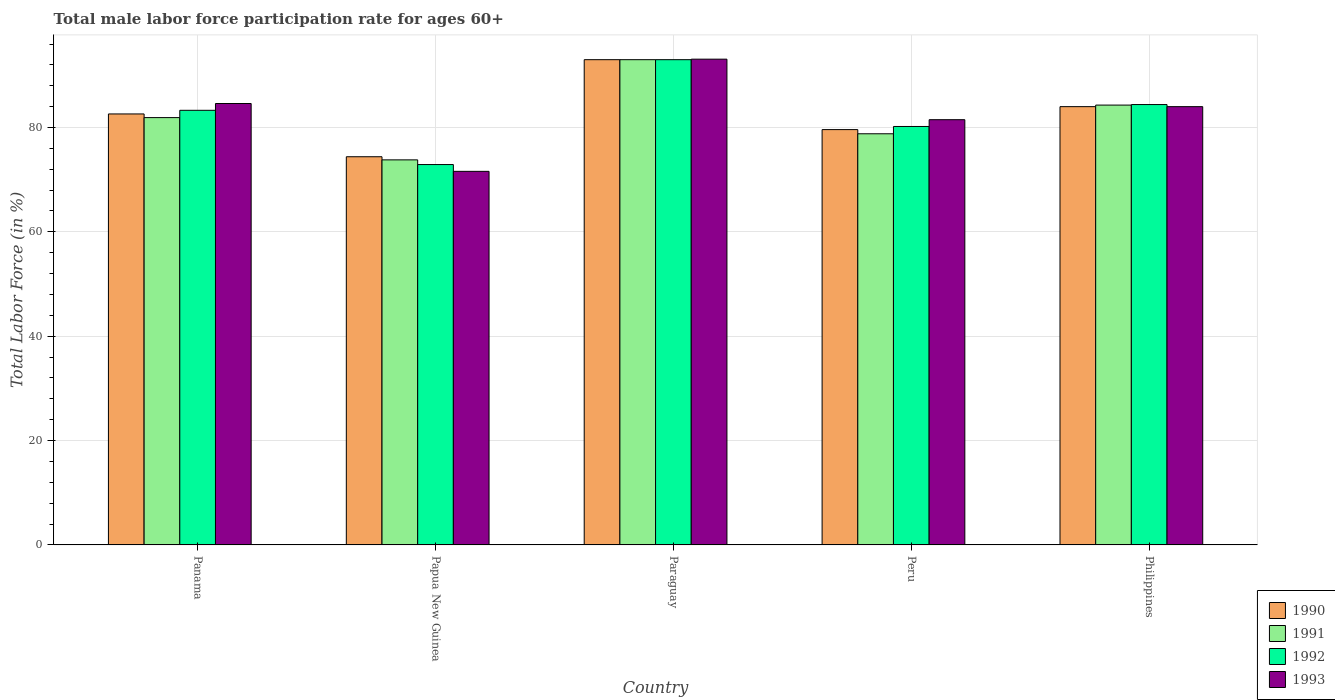Are the number of bars on each tick of the X-axis equal?
Provide a short and direct response. Yes. How many bars are there on the 3rd tick from the left?
Ensure brevity in your answer.  4. How many bars are there on the 5th tick from the right?
Ensure brevity in your answer.  4. What is the label of the 1st group of bars from the left?
Give a very brief answer. Panama. What is the male labor force participation rate in 1992 in Peru?
Your response must be concise. 80.2. Across all countries, what is the maximum male labor force participation rate in 1993?
Provide a succinct answer. 93.1. Across all countries, what is the minimum male labor force participation rate in 1992?
Provide a succinct answer. 72.9. In which country was the male labor force participation rate in 1991 maximum?
Offer a very short reply. Paraguay. In which country was the male labor force participation rate in 1991 minimum?
Make the answer very short. Papua New Guinea. What is the total male labor force participation rate in 1991 in the graph?
Your response must be concise. 411.8. What is the difference between the male labor force participation rate in 1993 in Paraguay and that in Philippines?
Your answer should be compact. 9.1. What is the difference between the male labor force participation rate in 1991 in Papua New Guinea and the male labor force participation rate in 1992 in Paraguay?
Provide a succinct answer. -19.2. What is the average male labor force participation rate in 1993 per country?
Offer a very short reply. 82.96. What is the difference between the male labor force participation rate of/in 1993 and male labor force participation rate of/in 1991 in Papua New Guinea?
Your response must be concise. -2.2. In how many countries, is the male labor force participation rate in 1990 greater than 48 %?
Offer a very short reply. 5. What is the ratio of the male labor force participation rate in 1990 in Panama to that in Papua New Guinea?
Your answer should be compact. 1.11. Is the male labor force participation rate in 1990 in Papua New Guinea less than that in Paraguay?
Make the answer very short. Yes. What is the difference between the highest and the second highest male labor force participation rate in 1991?
Keep it short and to the point. -2.4. What is the difference between the highest and the lowest male labor force participation rate in 1990?
Provide a succinct answer. 18.6. In how many countries, is the male labor force participation rate in 1991 greater than the average male labor force participation rate in 1991 taken over all countries?
Make the answer very short. 2. Is it the case that in every country, the sum of the male labor force participation rate in 1990 and male labor force participation rate in 1991 is greater than the sum of male labor force participation rate in 1993 and male labor force participation rate in 1992?
Offer a very short reply. No. What does the 2nd bar from the left in Peru represents?
Offer a very short reply. 1991. What does the 3rd bar from the right in Panama represents?
Your answer should be very brief. 1991. Is it the case that in every country, the sum of the male labor force participation rate in 1993 and male labor force participation rate in 1991 is greater than the male labor force participation rate in 1992?
Your answer should be very brief. Yes. Are all the bars in the graph horizontal?
Make the answer very short. No. What is the difference between two consecutive major ticks on the Y-axis?
Offer a terse response. 20. Does the graph contain any zero values?
Give a very brief answer. No. How are the legend labels stacked?
Offer a very short reply. Vertical. What is the title of the graph?
Make the answer very short. Total male labor force participation rate for ages 60+. What is the label or title of the Y-axis?
Your answer should be compact. Total Labor Force (in %). What is the Total Labor Force (in %) of 1990 in Panama?
Your answer should be very brief. 82.6. What is the Total Labor Force (in %) of 1991 in Panama?
Offer a terse response. 81.9. What is the Total Labor Force (in %) in 1992 in Panama?
Offer a terse response. 83.3. What is the Total Labor Force (in %) in 1993 in Panama?
Offer a terse response. 84.6. What is the Total Labor Force (in %) of 1990 in Papua New Guinea?
Provide a succinct answer. 74.4. What is the Total Labor Force (in %) of 1991 in Papua New Guinea?
Keep it short and to the point. 73.8. What is the Total Labor Force (in %) of 1992 in Papua New Guinea?
Make the answer very short. 72.9. What is the Total Labor Force (in %) in 1993 in Papua New Guinea?
Provide a succinct answer. 71.6. What is the Total Labor Force (in %) in 1990 in Paraguay?
Give a very brief answer. 93. What is the Total Labor Force (in %) in 1991 in Paraguay?
Your response must be concise. 93. What is the Total Labor Force (in %) in 1992 in Paraguay?
Your response must be concise. 93. What is the Total Labor Force (in %) in 1993 in Paraguay?
Offer a very short reply. 93.1. What is the Total Labor Force (in %) of 1990 in Peru?
Make the answer very short. 79.6. What is the Total Labor Force (in %) of 1991 in Peru?
Give a very brief answer. 78.8. What is the Total Labor Force (in %) in 1992 in Peru?
Make the answer very short. 80.2. What is the Total Labor Force (in %) in 1993 in Peru?
Make the answer very short. 81.5. What is the Total Labor Force (in %) of 1990 in Philippines?
Provide a short and direct response. 84. What is the Total Labor Force (in %) of 1991 in Philippines?
Make the answer very short. 84.3. What is the Total Labor Force (in %) of 1992 in Philippines?
Offer a terse response. 84.4. What is the Total Labor Force (in %) of 1993 in Philippines?
Provide a succinct answer. 84. Across all countries, what is the maximum Total Labor Force (in %) in 1990?
Provide a succinct answer. 93. Across all countries, what is the maximum Total Labor Force (in %) of 1991?
Your answer should be compact. 93. Across all countries, what is the maximum Total Labor Force (in %) in 1992?
Make the answer very short. 93. Across all countries, what is the maximum Total Labor Force (in %) of 1993?
Provide a short and direct response. 93.1. Across all countries, what is the minimum Total Labor Force (in %) of 1990?
Offer a terse response. 74.4. Across all countries, what is the minimum Total Labor Force (in %) in 1991?
Your answer should be compact. 73.8. Across all countries, what is the minimum Total Labor Force (in %) in 1992?
Offer a very short reply. 72.9. Across all countries, what is the minimum Total Labor Force (in %) of 1993?
Your answer should be very brief. 71.6. What is the total Total Labor Force (in %) of 1990 in the graph?
Give a very brief answer. 413.6. What is the total Total Labor Force (in %) of 1991 in the graph?
Keep it short and to the point. 411.8. What is the total Total Labor Force (in %) in 1992 in the graph?
Provide a short and direct response. 413.8. What is the total Total Labor Force (in %) in 1993 in the graph?
Your answer should be very brief. 414.8. What is the difference between the Total Labor Force (in %) of 1990 in Panama and that in Papua New Guinea?
Keep it short and to the point. 8.2. What is the difference between the Total Labor Force (in %) in 1992 in Panama and that in Papua New Guinea?
Your answer should be very brief. 10.4. What is the difference between the Total Labor Force (in %) in 1991 in Panama and that in Paraguay?
Ensure brevity in your answer.  -11.1. What is the difference between the Total Labor Force (in %) in 1993 in Panama and that in Paraguay?
Keep it short and to the point. -8.5. What is the difference between the Total Labor Force (in %) of 1991 in Panama and that in Peru?
Your response must be concise. 3.1. What is the difference between the Total Labor Force (in %) in 1992 in Panama and that in Peru?
Keep it short and to the point. 3.1. What is the difference between the Total Labor Force (in %) of 1991 in Panama and that in Philippines?
Ensure brevity in your answer.  -2.4. What is the difference between the Total Labor Force (in %) of 1990 in Papua New Guinea and that in Paraguay?
Make the answer very short. -18.6. What is the difference between the Total Labor Force (in %) in 1991 in Papua New Guinea and that in Paraguay?
Keep it short and to the point. -19.2. What is the difference between the Total Labor Force (in %) of 1992 in Papua New Guinea and that in Paraguay?
Offer a very short reply. -20.1. What is the difference between the Total Labor Force (in %) in 1993 in Papua New Guinea and that in Paraguay?
Make the answer very short. -21.5. What is the difference between the Total Labor Force (in %) in 1990 in Papua New Guinea and that in Peru?
Provide a succinct answer. -5.2. What is the difference between the Total Labor Force (in %) in 1991 in Papua New Guinea and that in Peru?
Give a very brief answer. -5. What is the difference between the Total Labor Force (in %) in 1992 in Papua New Guinea and that in Peru?
Provide a succinct answer. -7.3. What is the difference between the Total Labor Force (in %) of 1993 in Papua New Guinea and that in Peru?
Your answer should be very brief. -9.9. What is the difference between the Total Labor Force (in %) in 1991 in Papua New Guinea and that in Philippines?
Ensure brevity in your answer.  -10.5. What is the difference between the Total Labor Force (in %) of 1992 in Paraguay and that in Peru?
Offer a very short reply. 12.8. What is the difference between the Total Labor Force (in %) in 1990 in Paraguay and that in Philippines?
Offer a terse response. 9. What is the difference between the Total Labor Force (in %) of 1991 in Paraguay and that in Philippines?
Make the answer very short. 8.7. What is the difference between the Total Labor Force (in %) of 1993 in Paraguay and that in Philippines?
Make the answer very short. 9.1. What is the difference between the Total Labor Force (in %) in 1990 in Peru and that in Philippines?
Provide a short and direct response. -4.4. What is the difference between the Total Labor Force (in %) of 1990 in Panama and the Total Labor Force (in %) of 1991 in Papua New Guinea?
Provide a short and direct response. 8.8. What is the difference between the Total Labor Force (in %) of 1990 in Panama and the Total Labor Force (in %) of 1992 in Paraguay?
Your response must be concise. -10.4. What is the difference between the Total Labor Force (in %) of 1990 in Panama and the Total Labor Force (in %) of 1993 in Paraguay?
Ensure brevity in your answer.  -10.5. What is the difference between the Total Labor Force (in %) in 1991 in Panama and the Total Labor Force (in %) in 1992 in Paraguay?
Provide a succinct answer. -11.1. What is the difference between the Total Labor Force (in %) in 1991 in Panama and the Total Labor Force (in %) in 1992 in Peru?
Keep it short and to the point. 1.7. What is the difference between the Total Labor Force (in %) of 1991 in Panama and the Total Labor Force (in %) of 1993 in Peru?
Your answer should be compact. 0.4. What is the difference between the Total Labor Force (in %) of 1990 in Panama and the Total Labor Force (in %) of 1992 in Philippines?
Provide a succinct answer. -1.8. What is the difference between the Total Labor Force (in %) of 1990 in Panama and the Total Labor Force (in %) of 1993 in Philippines?
Offer a very short reply. -1.4. What is the difference between the Total Labor Force (in %) in 1991 in Panama and the Total Labor Force (in %) in 1992 in Philippines?
Offer a terse response. -2.5. What is the difference between the Total Labor Force (in %) of 1992 in Panama and the Total Labor Force (in %) of 1993 in Philippines?
Keep it short and to the point. -0.7. What is the difference between the Total Labor Force (in %) in 1990 in Papua New Guinea and the Total Labor Force (in %) in 1991 in Paraguay?
Give a very brief answer. -18.6. What is the difference between the Total Labor Force (in %) in 1990 in Papua New Guinea and the Total Labor Force (in %) in 1992 in Paraguay?
Your answer should be compact. -18.6. What is the difference between the Total Labor Force (in %) of 1990 in Papua New Guinea and the Total Labor Force (in %) of 1993 in Paraguay?
Keep it short and to the point. -18.7. What is the difference between the Total Labor Force (in %) in 1991 in Papua New Guinea and the Total Labor Force (in %) in 1992 in Paraguay?
Offer a very short reply. -19.2. What is the difference between the Total Labor Force (in %) of 1991 in Papua New Guinea and the Total Labor Force (in %) of 1993 in Paraguay?
Your answer should be very brief. -19.3. What is the difference between the Total Labor Force (in %) in 1992 in Papua New Guinea and the Total Labor Force (in %) in 1993 in Paraguay?
Provide a short and direct response. -20.2. What is the difference between the Total Labor Force (in %) in 1990 in Papua New Guinea and the Total Labor Force (in %) in 1991 in Peru?
Offer a terse response. -4.4. What is the difference between the Total Labor Force (in %) in 1990 in Papua New Guinea and the Total Labor Force (in %) in 1992 in Peru?
Provide a succinct answer. -5.8. What is the difference between the Total Labor Force (in %) of 1990 in Papua New Guinea and the Total Labor Force (in %) of 1993 in Peru?
Make the answer very short. -7.1. What is the difference between the Total Labor Force (in %) in 1991 in Papua New Guinea and the Total Labor Force (in %) in 1992 in Peru?
Your answer should be very brief. -6.4. What is the difference between the Total Labor Force (in %) of 1992 in Papua New Guinea and the Total Labor Force (in %) of 1993 in Peru?
Your answer should be compact. -8.6. What is the difference between the Total Labor Force (in %) of 1990 in Papua New Guinea and the Total Labor Force (in %) of 1991 in Philippines?
Offer a terse response. -9.9. What is the difference between the Total Labor Force (in %) in 1990 in Papua New Guinea and the Total Labor Force (in %) in 1992 in Philippines?
Keep it short and to the point. -10. What is the difference between the Total Labor Force (in %) in 1992 in Papua New Guinea and the Total Labor Force (in %) in 1993 in Philippines?
Make the answer very short. -11.1. What is the difference between the Total Labor Force (in %) in 1990 in Paraguay and the Total Labor Force (in %) in 1991 in Peru?
Provide a succinct answer. 14.2. What is the difference between the Total Labor Force (in %) of 1990 in Paraguay and the Total Labor Force (in %) of 1992 in Peru?
Provide a succinct answer. 12.8. What is the difference between the Total Labor Force (in %) in 1990 in Paraguay and the Total Labor Force (in %) in 1993 in Peru?
Make the answer very short. 11.5. What is the difference between the Total Labor Force (in %) of 1991 in Paraguay and the Total Labor Force (in %) of 1992 in Peru?
Provide a succinct answer. 12.8. What is the difference between the Total Labor Force (in %) in 1992 in Paraguay and the Total Labor Force (in %) in 1993 in Peru?
Your response must be concise. 11.5. What is the difference between the Total Labor Force (in %) in 1990 in Paraguay and the Total Labor Force (in %) in 1991 in Philippines?
Provide a short and direct response. 8.7. What is the difference between the Total Labor Force (in %) of 1990 in Paraguay and the Total Labor Force (in %) of 1993 in Philippines?
Keep it short and to the point. 9. What is the difference between the Total Labor Force (in %) in 1991 in Paraguay and the Total Labor Force (in %) in 1992 in Philippines?
Make the answer very short. 8.6. What is the difference between the Total Labor Force (in %) of 1991 in Peru and the Total Labor Force (in %) of 1992 in Philippines?
Your answer should be very brief. -5.6. What is the difference between the Total Labor Force (in %) in 1991 in Peru and the Total Labor Force (in %) in 1993 in Philippines?
Offer a terse response. -5.2. What is the average Total Labor Force (in %) in 1990 per country?
Make the answer very short. 82.72. What is the average Total Labor Force (in %) of 1991 per country?
Keep it short and to the point. 82.36. What is the average Total Labor Force (in %) in 1992 per country?
Make the answer very short. 82.76. What is the average Total Labor Force (in %) of 1993 per country?
Provide a short and direct response. 82.96. What is the difference between the Total Labor Force (in %) in 1990 and Total Labor Force (in %) in 1991 in Panama?
Offer a terse response. 0.7. What is the difference between the Total Labor Force (in %) in 1990 and Total Labor Force (in %) in 1993 in Panama?
Offer a terse response. -2. What is the difference between the Total Labor Force (in %) in 1991 and Total Labor Force (in %) in 1992 in Panama?
Your response must be concise. -1.4. What is the difference between the Total Labor Force (in %) in 1990 and Total Labor Force (in %) in 1991 in Papua New Guinea?
Offer a terse response. 0.6. What is the difference between the Total Labor Force (in %) of 1990 and Total Labor Force (in %) of 1992 in Papua New Guinea?
Keep it short and to the point. 1.5. What is the difference between the Total Labor Force (in %) in 1991 and Total Labor Force (in %) in 1992 in Papua New Guinea?
Offer a very short reply. 0.9. What is the difference between the Total Labor Force (in %) of 1990 and Total Labor Force (in %) of 1992 in Paraguay?
Your answer should be compact. 0. What is the difference between the Total Labor Force (in %) in 1990 and Total Labor Force (in %) in 1993 in Paraguay?
Provide a succinct answer. -0.1. What is the difference between the Total Labor Force (in %) in 1991 and Total Labor Force (in %) in 1992 in Paraguay?
Provide a succinct answer. 0. What is the difference between the Total Labor Force (in %) of 1991 and Total Labor Force (in %) of 1993 in Paraguay?
Ensure brevity in your answer.  -0.1. What is the difference between the Total Labor Force (in %) in 1990 and Total Labor Force (in %) in 1992 in Peru?
Keep it short and to the point. -0.6. What is the difference between the Total Labor Force (in %) in 1991 and Total Labor Force (in %) in 1993 in Peru?
Offer a very short reply. -2.7. What is the difference between the Total Labor Force (in %) of 1992 and Total Labor Force (in %) of 1993 in Peru?
Offer a very short reply. -1.3. What is the difference between the Total Labor Force (in %) in 1991 and Total Labor Force (in %) in 1992 in Philippines?
Your answer should be compact. -0.1. What is the ratio of the Total Labor Force (in %) in 1990 in Panama to that in Papua New Guinea?
Your answer should be compact. 1.11. What is the ratio of the Total Labor Force (in %) in 1991 in Panama to that in Papua New Guinea?
Keep it short and to the point. 1.11. What is the ratio of the Total Labor Force (in %) in 1992 in Panama to that in Papua New Guinea?
Your answer should be very brief. 1.14. What is the ratio of the Total Labor Force (in %) in 1993 in Panama to that in Papua New Guinea?
Provide a short and direct response. 1.18. What is the ratio of the Total Labor Force (in %) in 1990 in Panama to that in Paraguay?
Offer a terse response. 0.89. What is the ratio of the Total Labor Force (in %) of 1991 in Panama to that in Paraguay?
Provide a succinct answer. 0.88. What is the ratio of the Total Labor Force (in %) in 1992 in Panama to that in Paraguay?
Provide a short and direct response. 0.9. What is the ratio of the Total Labor Force (in %) in 1993 in Panama to that in Paraguay?
Your answer should be very brief. 0.91. What is the ratio of the Total Labor Force (in %) of 1990 in Panama to that in Peru?
Make the answer very short. 1.04. What is the ratio of the Total Labor Force (in %) in 1991 in Panama to that in Peru?
Make the answer very short. 1.04. What is the ratio of the Total Labor Force (in %) in 1992 in Panama to that in Peru?
Keep it short and to the point. 1.04. What is the ratio of the Total Labor Force (in %) in 1993 in Panama to that in Peru?
Keep it short and to the point. 1.04. What is the ratio of the Total Labor Force (in %) of 1990 in Panama to that in Philippines?
Offer a terse response. 0.98. What is the ratio of the Total Labor Force (in %) of 1991 in Panama to that in Philippines?
Your response must be concise. 0.97. What is the ratio of the Total Labor Force (in %) of 1993 in Panama to that in Philippines?
Ensure brevity in your answer.  1.01. What is the ratio of the Total Labor Force (in %) in 1991 in Papua New Guinea to that in Paraguay?
Give a very brief answer. 0.79. What is the ratio of the Total Labor Force (in %) in 1992 in Papua New Guinea to that in Paraguay?
Ensure brevity in your answer.  0.78. What is the ratio of the Total Labor Force (in %) of 1993 in Papua New Guinea to that in Paraguay?
Provide a short and direct response. 0.77. What is the ratio of the Total Labor Force (in %) in 1990 in Papua New Guinea to that in Peru?
Offer a very short reply. 0.93. What is the ratio of the Total Labor Force (in %) of 1991 in Papua New Guinea to that in Peru?
Provide a succinct answer. 0.94. What is the ratio of the Total Labor Force (in %) in 1992 in Papua New Guinea to that in Peru?
Keep it short and to the point. 0.91. What is the ratio of the Total Labor Force (in %) in 1993 in Papua New Guinea to that in Peru?
Offer a terse response. 0.88. What is the ratio of the Total Labor Force (in %) in 1990 in Papua New Guinea to that in Philippines?
Provide a short and direct response. 0.89. What is the ratio of the Total Labor Force (in %) of 1991 in Papua New Guinea to that in Philippines?
Provide a short and direct response. 0.88. What is the ratio of the Total Labor Force (in %) of 1992 in Papua New Guinea to that in Philippines?
Your answer should be very brief. 0.86. What is the ratio of the Total Labor Force (in %) in 1993 in Papua New Guinea to that in Philippines?
Provide a short and direct response. 0.85. What is the ratio of the Total Labor Force (in %) in 1990 in Paraguay to that in Peru?
Provide a succinct answer. 1.17. What is the ratio of the Total Labor Force (in %) in 1991 in Paraguay to that in Peru?
Provide a short and direct response. 1.18. What is the ratio of the Total Labor Force (in %) of 1992 in Paraguay to that in Peru?
Your answer should be very brief. 1.16. What is the ratio of the Total Labor Force (in %) of 1993 in Paraguay to that in Peru?
Your answer should be compact. 1.14. What is the ratio of the Total Labor Force (in %) of 1990 in Paraguay to that in Philippines?
Your answer should be compact. 1.11. What is the ratio of the Total Labor Force (in %) of 1991 in Paraguay to that in Philippines?
Provide a succinct answer. 1.1. What is the ratio of the Total Labor Force (in %) in 1992 in Paraguay to that in Philippines?
Provide a short and direct response. 1.1. What is the ratio of the Total Labor Force (in %) of 1993 in Paraguay to that in Philippines?
Offer a very short reply. 1.11. What is the ratio of the Total Labor Force (in %) of 1990 in Peru to that in Philippines?
Make the answer very short. 0.95. What is the ratio of the Total Labor Force (in %) of 1991 in Peru to that in Philippines?
Offer a very short reply. 0.93. What is the ratio of the Total Labor Force (in %) in 1992 in Peru to that in Philippines?
Your answer should be very brief. 0.95. What is the ratio of the Total Labor Force (in %) in 1993 in Peru to that in Philippines?
Your answer should be compact. 0.97. What is the difference between the highest and the second highest Total Labor Force (in %) in 1990?
Make the answer very short. 9. What is the difference between the highest and the second highest Total Labor Force (in %) of 1991?
Offer a terse response. 8.7. What is the difference between the highest and the lowest Total Labor Force (in %) of 1990?
Offer a very short reply. 18.6. What is the difference between the highest and the lowest Total Labor Force (in %) of 1991?
Offer a terse response. 19.2. What is the difference between the highest and the lowest Total Labor Force (in %) of 1992?
Keep it short and to the point. 20.1. What is the difference between the highest and the lowest Total Labor Force (in %) of 1993?
Ensure brevity in your answer.  21.5. 